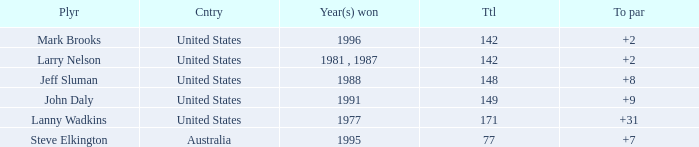Name the To par that has a Year(s) won of 1988 and a Total smaller than 148? None. 